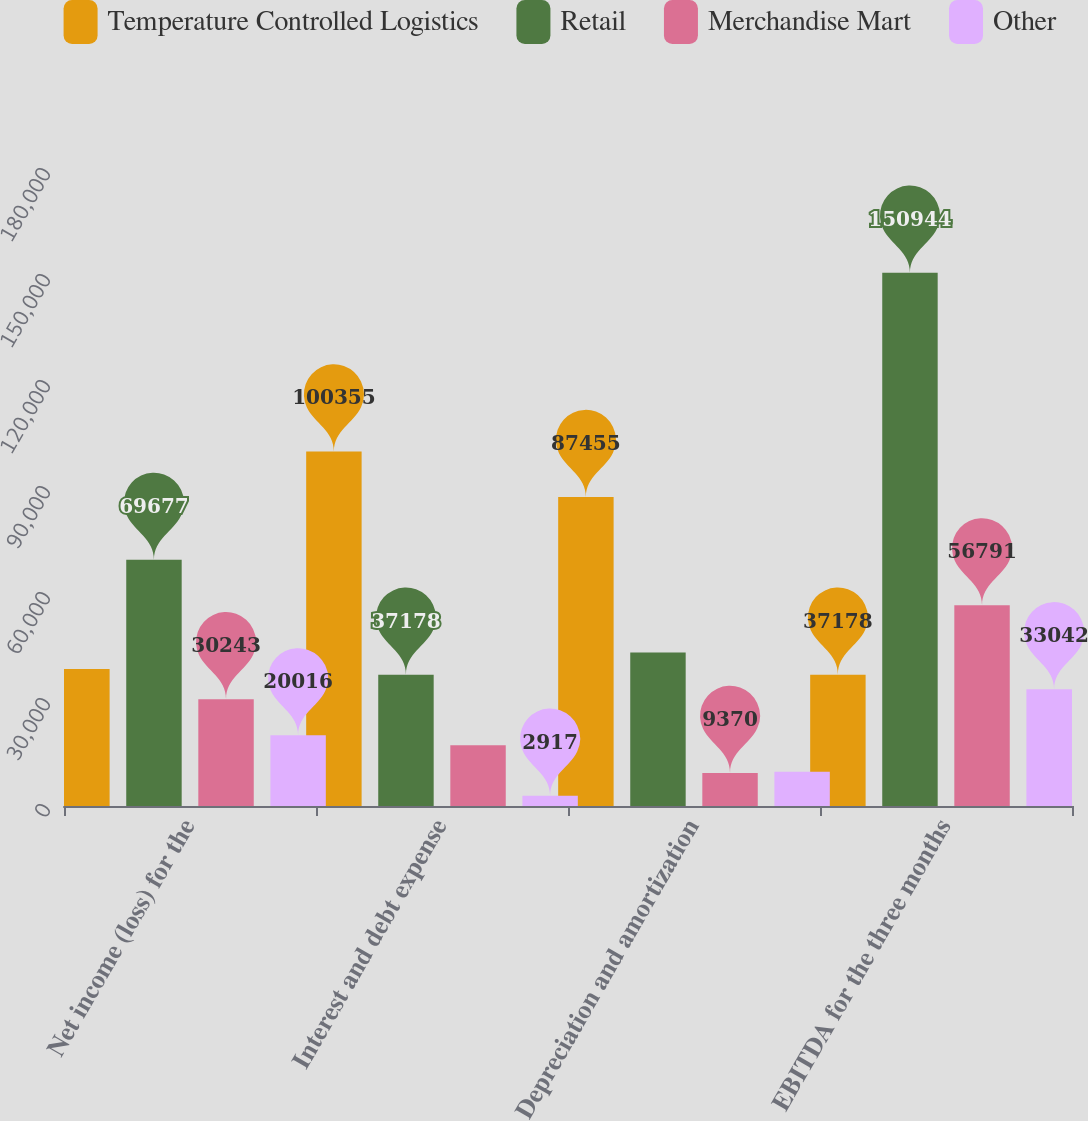Convert chart to OTSL. <chart><loc_0><loc_0><loc_500><loc_500><stacked_bar_chart><ecel><fcel>Net income (loss) for the<fcel>Interest and debt expense<fcel>Depreciation and amortization<fcel>EBITDA for the three months<nl><fcel>Temperature Controlled Logistics<fcel>38742<fcel>100355<fcel>87455<fcel>37178<nl><fcel>Retail<fcel>69677<fcel>37178<fcel>43455<fcel>150944<nl><fcel>Merchandise Mart<fcel>30243<fcel>17178<fcel>9370<fcel>56791<nl><fcel>Other<fcel>20016<fcel>2917<fcel>9670<fcel>33042<nl></chart> 